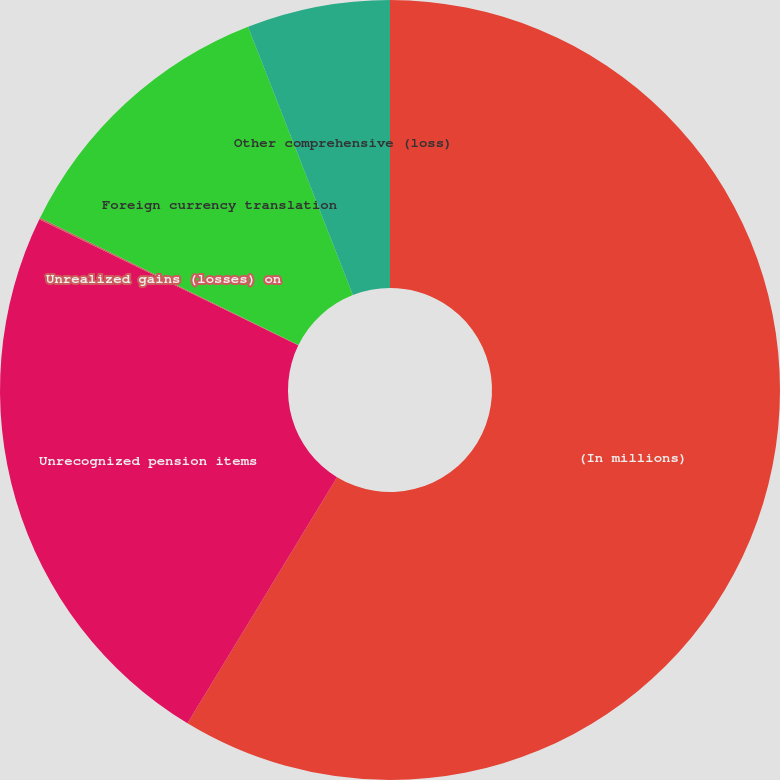Convert chart to OTSL. <chart><loc_0><loc_0><loc_500><loc_500><pie_chart><fcel>(In millions)<fcel>Unrecognized pension items<fcel>Unrealized gains (losses) on<fcel>Foreign currency translation<fcel>Other comprehensive (loss)<nl><fcel>58.69%<fcel>23.52%<fcel>0.07%<fcel>11.79%<fcel>5.93%<nl></chart> 